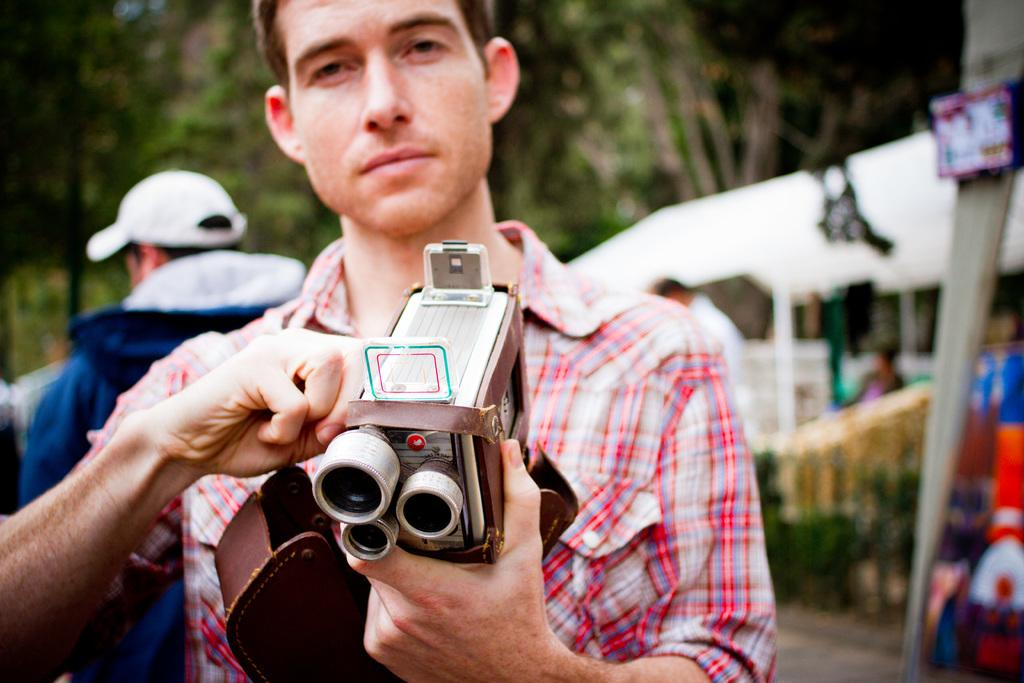What is the main subject of the image? There is a person standing in the image. What is the person holding in his hand? The person is holding an object in his hand. Can you describe the position of the second person in the image? There is another person behind the first person on the left side. What can be seen in the background of the image? There are trees visible in the background of the image. How many bushes are visible in the image? There are no bushes mentioned or visible in the image. Are the two people in the image sisters? The relationship between the two people in the image is not mentioned or indicated in the provided facts. 